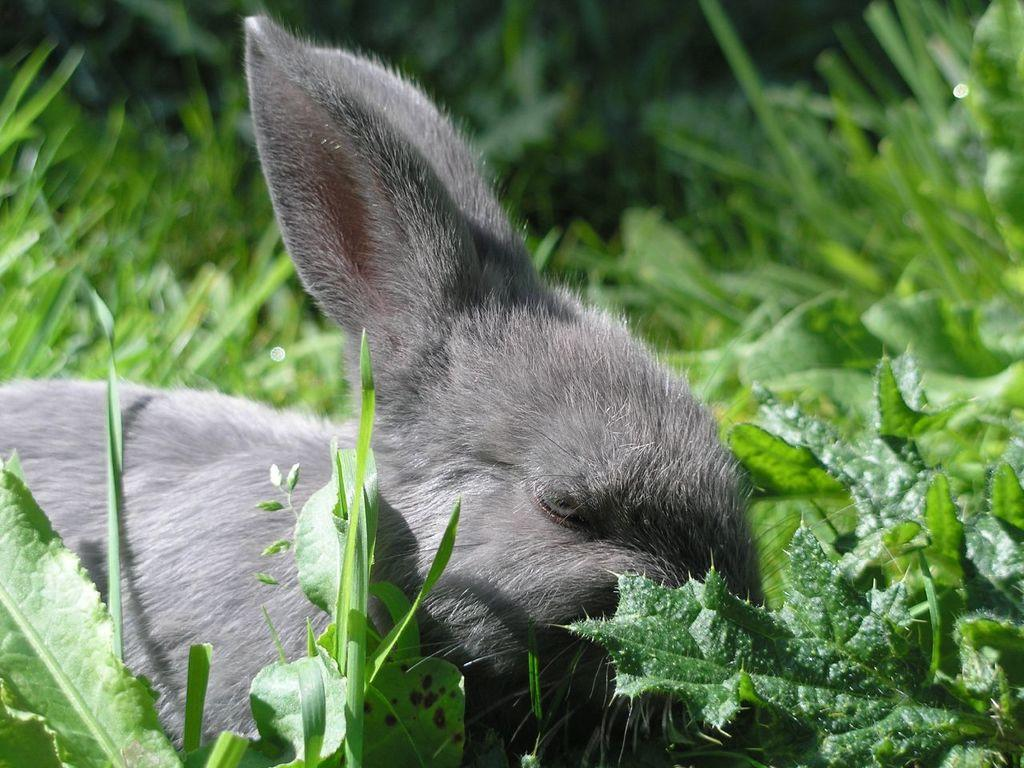What type of creature is present in the image? There is an animal in the image. What is the animal doing in the image? The animal is sleeping. What is the ground covered with in the image? The ground in the image is covered with greenery. Where can plants be found in the image? There are plants in the right corner of the image. What type of experience does the cloud have in the image? There is no cloud present in the image, so it is not possible to discuss any experiences related to a cloud. 